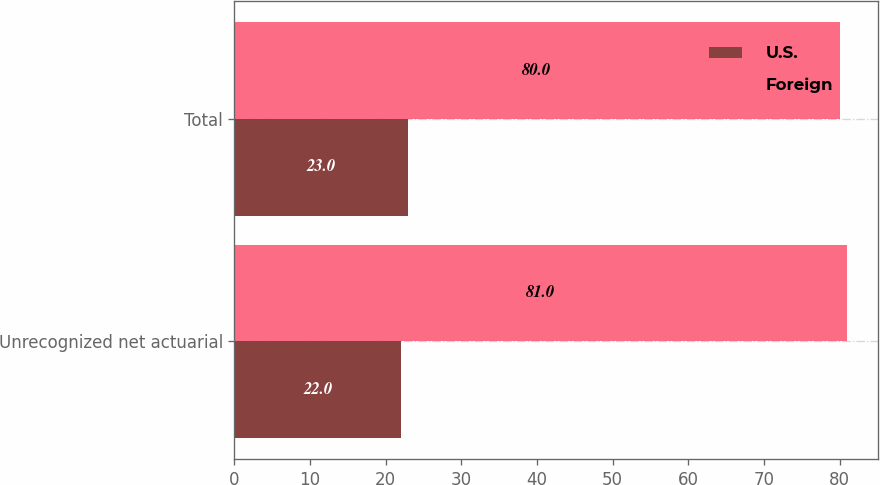Convert chart to OTSL. <chart><loc_0><loc_0><loc_500><loc_500><stacked_bar_chart><ecel><fcel>Unrecognized net actuarial<fcel>Total<nl><fcel>U.S.<fcel>22<fcel>23<nl><fcel>Foreign<fcel>81<fcel>80<nl></chart> 